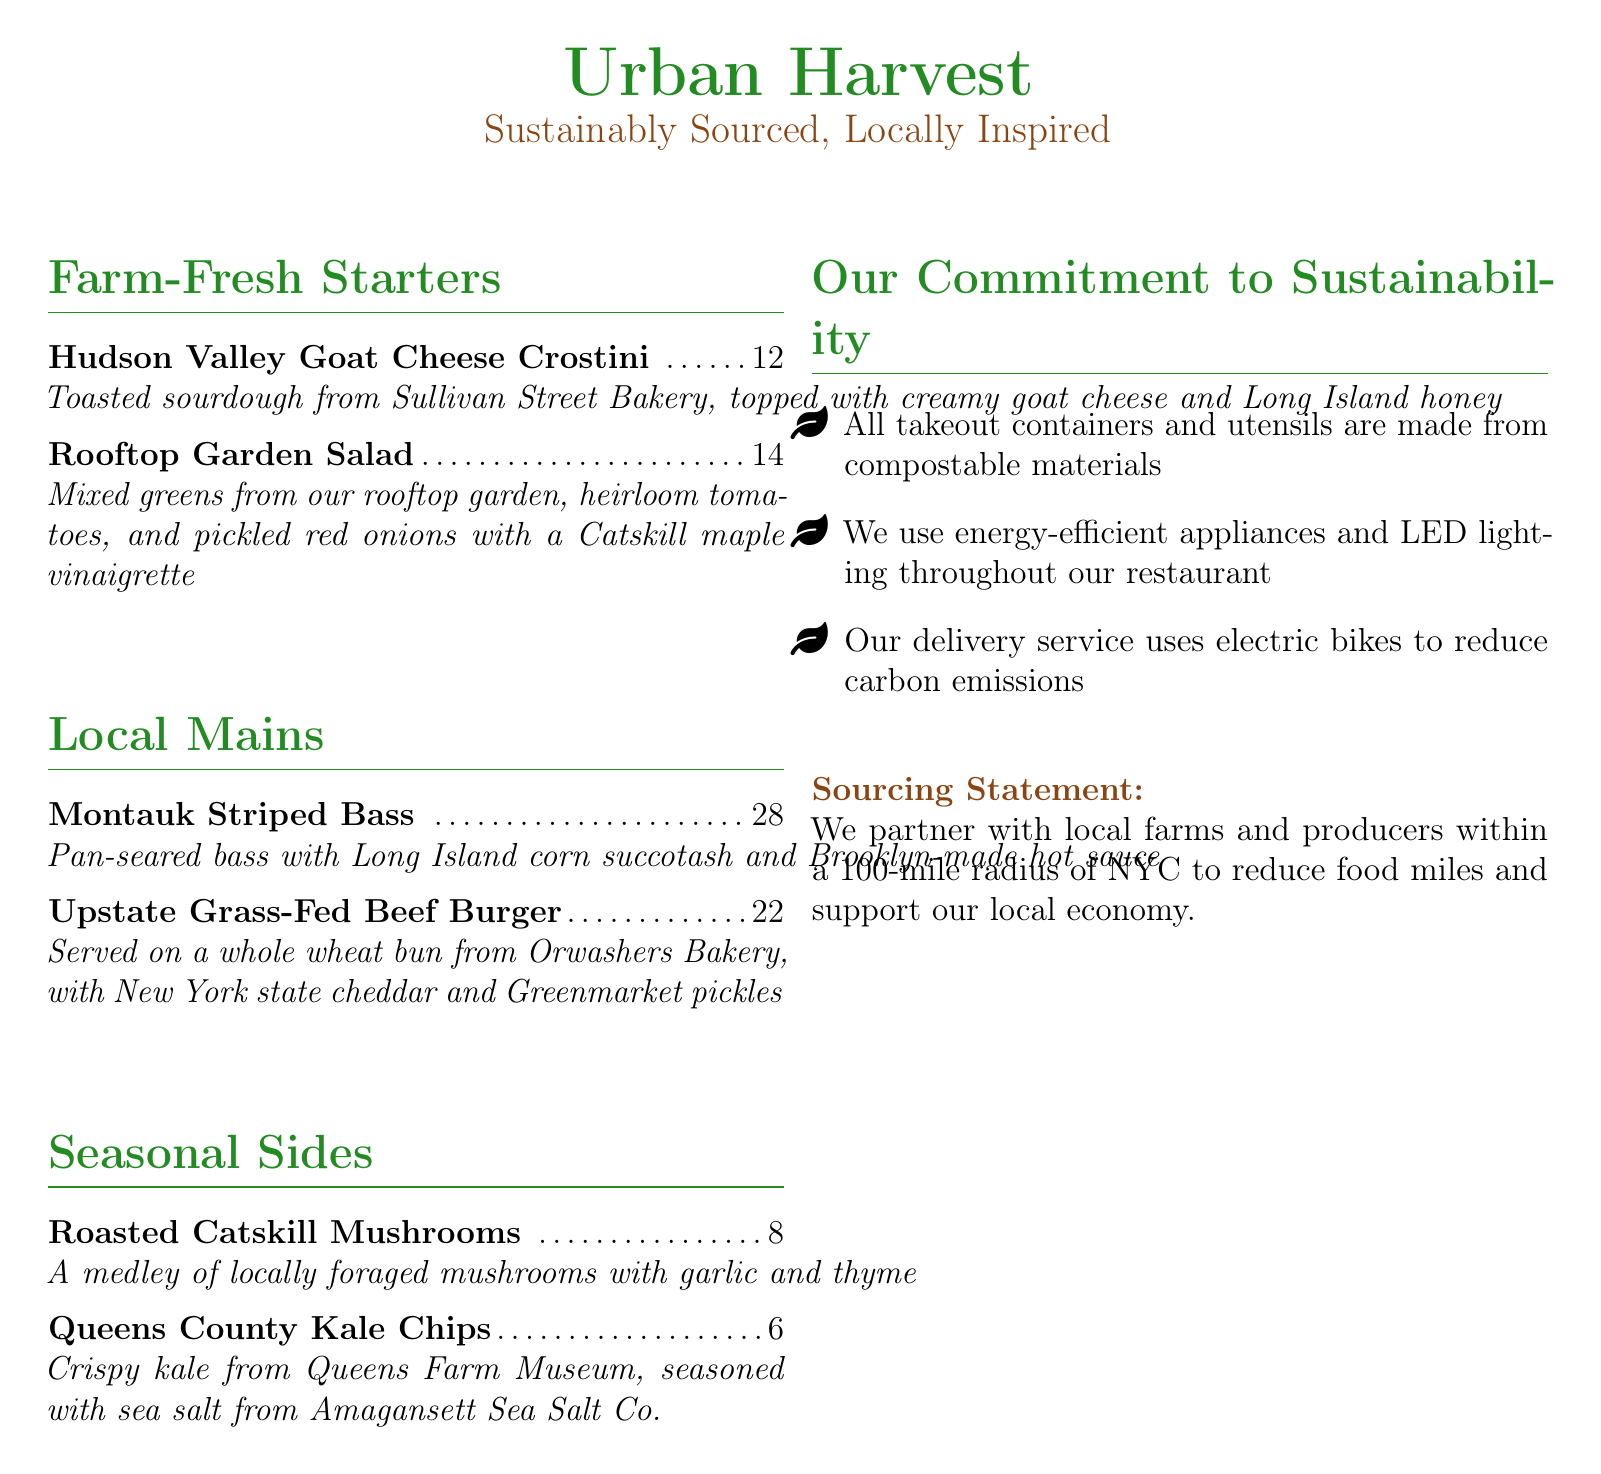What is the name of the restaurant? The name of the restaurant is prominently displayed at the top of the menu.
Answer: Urban Harvest What type of cheese is used in the Hudson Valley Goat Cheese Crostini? The document specifically mentions the type of cheese in the description of the dish.
Answer: Goat cheese What is the price of the Upstate Grass-Fed Beef Burger? The price of each menu item is listed next to the item name in the menu.
Answer: $22 Where do the mixed greens in the Rooftop Garden Salad come from? The source of the mixed greens is indicated in the item description on the menu.
Answer: Rooftop garden What type of mushrooms are served as a side? The side dish includes a description of the mushrooms used.
Answer: Locally foraged mushrooms What utensils are used for takeout? The sustainability commitment section mentions the type of materials used.
Answer: Compostable materials How are the restaurant's delivery services characterized? A detail in the sustainability section specifies the method of delivery.
Answer: Electric bikes What is the main ingredient in the Montauk Striped Bass dish? The dish description includes the main protein source.
Answer: Striped bass What type of packaging does Urban Harvest focus on? The sustainability commitment section mentions the focus of their takeout packaging.
Answer: Eco-friendly 